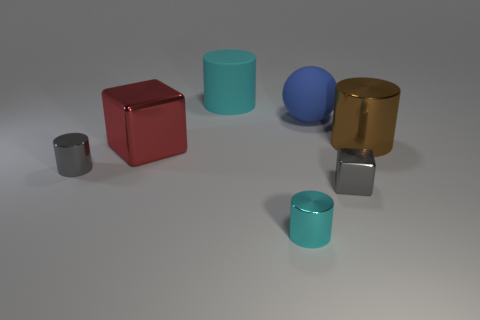The gray object that is the same shape as the tiny cyan metallic thing is what size?
Your answer should be very brief. Small. What material is the cylinder that is on the left side of the cylinder behind the large brown shiny object?
Give a very brief answer. Metal. What number of metal things are tiny cylinders or big cylinders?
Give a very brief answer. 3. What color is the other large object that is the same shape as the big brown metallic thing?
Provide a short and direct response. Cyan. How many tiny metal objects are the same color as the tiny metal cube?
Ensure brevity in your answer.  1. There is a big shiny thing that is right of the big ball; is there a brown metal cylinder that is left of it?
Provide a succinct answer. No. What number of objects are behind the big blue matte object and in front of the big red shiny block?
Ensure brevity in your answer.  0. What number of gray things have the same material as the big cube?
Provide a succinct answer. 2. How big is the cube that is in front of the cylinder that is to the left of the big cyan cylinder?
Give a very brief answer. Small. Are there any red things of the same shape as the big brown metallic thing?
Your answer should be very brief. No. 